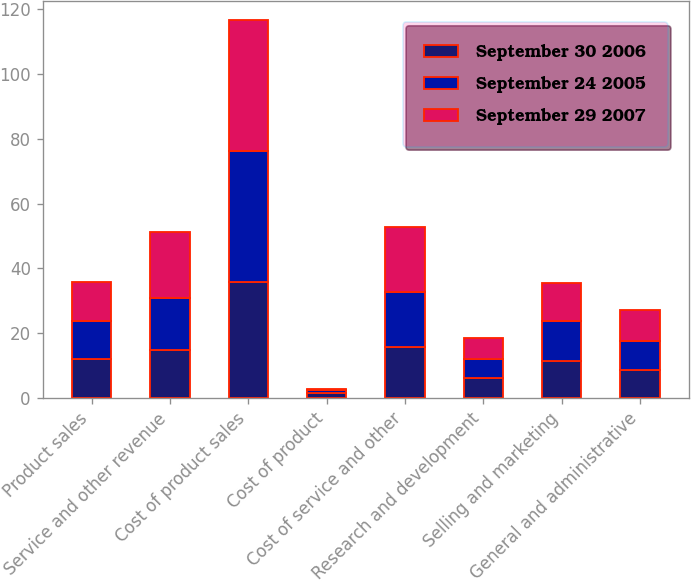Convert chart to OTSL. <chart><loc_0><loc_0><loc_500><loc_500><stacked_bar_chart><ecel><fcel>Product sales<fcel>Service and other revenue<fcel>Cost of product sales<fcel>Cost of product<fcel>Cost of service and other<fcel>Research and development<fcel>Selling and marketing<fcel>General and administrative<nl><fcel>September 30 2006<fcel>11.9<fcel>14.8<fcel>35.9<fcel>1.5<fcel>15.8<fcel>6<fcel>11.5<fcel>8.5<nl><fcel>September 24 2005<fcel>11.9<fcel>16.1<fcel>40.4<fcel>1<fcel>16.8<fcel>6.1<fcel>12.1<fcel>9.2<nl><fcel>September 29 2007<fcel>11.9<fcel>20.4<fcel>40.5<fcel>0.3<fcel>20.2<fcel>6.5<fcel>11.9<fcel>9.3<nl></chart> 